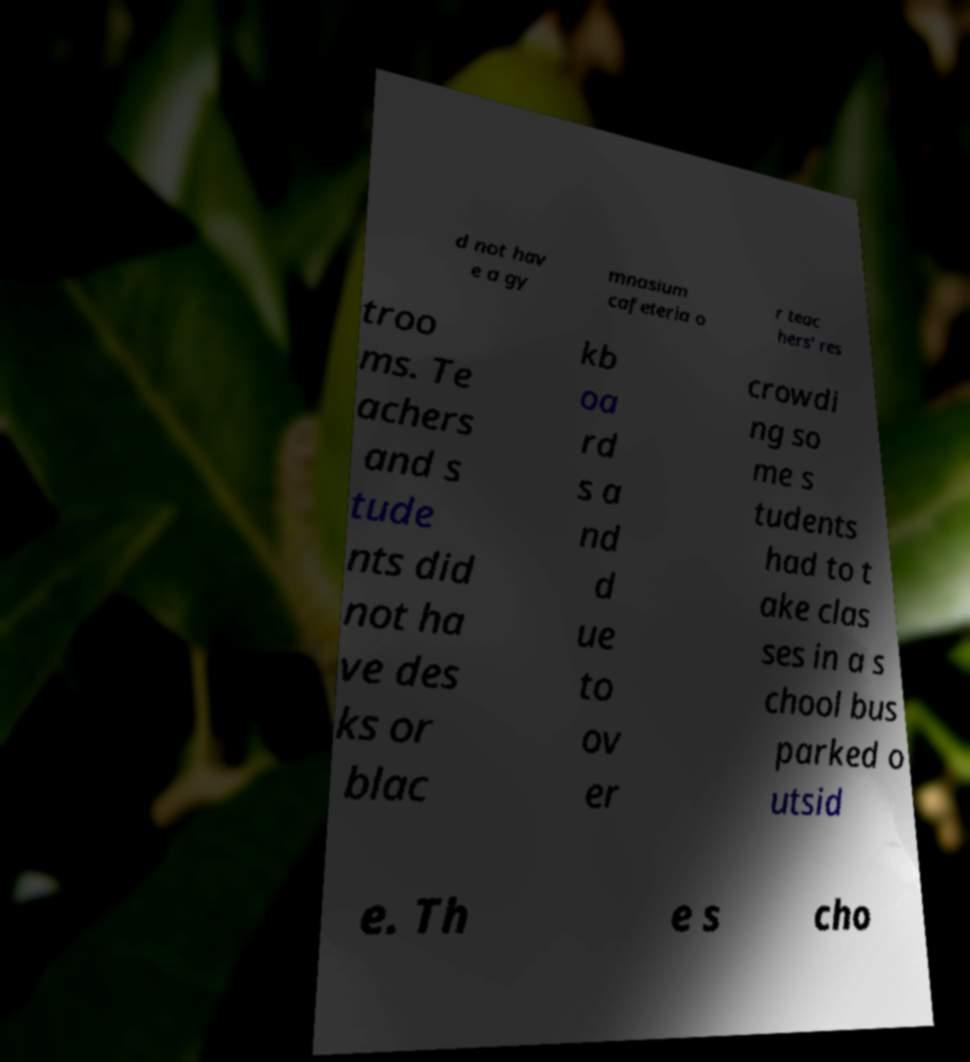There's text embedded in this image that I need extracted. Can you transcribe it verbatim? d not hav e a gy mnasium cafeteria o r teac hers' res troo ms. Te achers and s tude nts did not ha ve des ks or blac kb oa rd s a nd d ue to ov er crowdi ng so me s tudents had to t ake clas ses in a s chool bus parked o utsid e. Th e s cho 